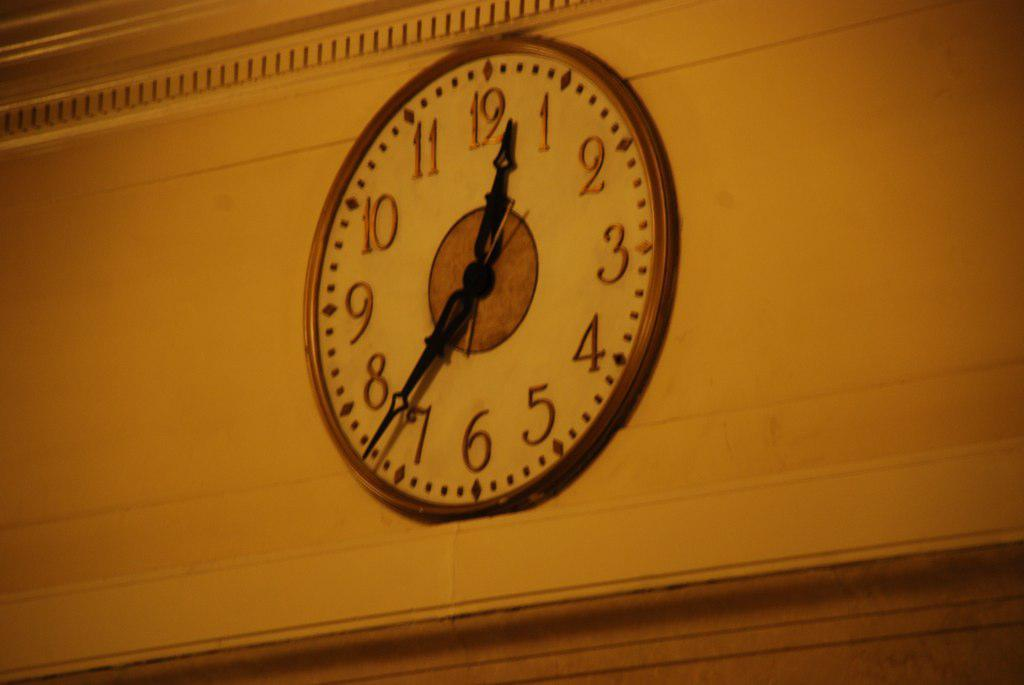Provide a one-sentence caption for the provided image. A clock hanging on a white brick wall shows the time as 12:37. 